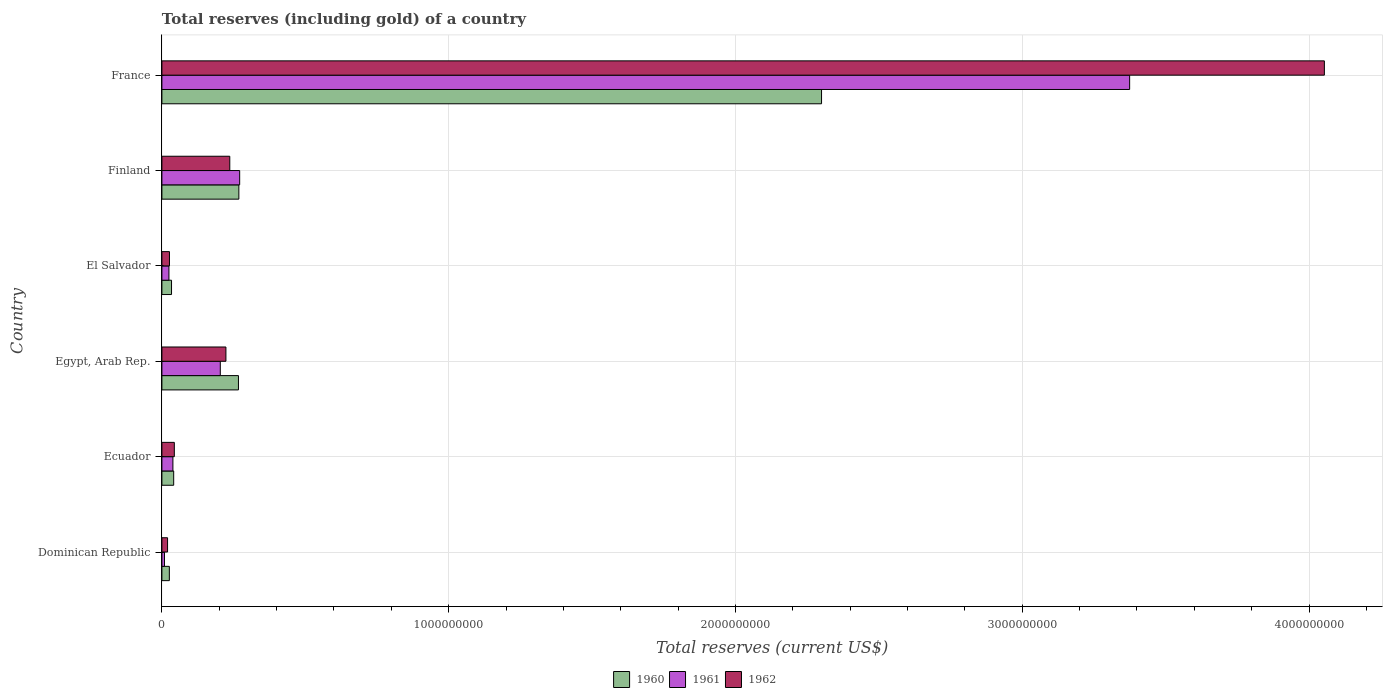How many different coloured bars are there?
Provide a short and direct response. 3. How many groups of bars are there?
Ensure brevity in your answer.  6. Are the number of bars on each tick of the Y-axis equal?
Make the answer very short. Yes. How many bars are there on the 1st tick from the bottom?
Keep it short and to the point. 3. What is the label of the 6th group of bars from the top?
Keep it short and to the point. Dominican Republic. What is the total reserves (including gold) in 1961 in Dominican Republic?
Provide a short and direct response. 9.02e+06. Across all countries, what is the maximum total reserves (including gold) in 1962?
Make the answer very short. 4.05e+09. Across all countries, what is the minimum total reserves (including gold) in 1961?
Ensure brevity in your answer.  9.02e+06. In which country was the total reserves (including gold) in 1961 minimum?
Keep it short and to the point. Dominican Republic. What is the total total reserves (including gold) in 1961 in the graph?
Give a very brief answer. 3.92e+09. What is the difference between the total reserves (including gold) in 1962 in Egypt, Arab Rep. and that in France?
Keep it short and to the point. -3.83e+09. What is the difference between the total reserves (including gold) in 1962 in El Salvador and the total reserves (including gold) in 1961 in Egypt, Arab Rep.?
Keep it short and to the point. -1.77e+08. What is the average total reserves (including gold) in 1962 per country?
Give a very brief answer. 7.67e+08. What is the difference between the total reserves (including gold) in 1962 and total reserves (including gold) in 1960 in Ecuador?
Ensure brevity in your answer.  2.27e+06. In how many countries, is the total reserves (including gold) in 1962 greater than 4000000000 US$?
Your answer should be compact. 1. What is the ratio of the total reserves (including gold) in 1961 in Ecuador to that in France?
Offer a terse response. 0.01. Is the difference between the total reserves (including gold) in 1962 in Dominican Republic and Ecuador greater than the difference between the total reserves (including gold) in 1960 in Dominican Republic and Ecuador?
Your answer should be compact. No. What is the difference between the highest and the second highest total reserves (including gold) in 1962?
Provide a succinct answer. 3.82e+09. What is the difference between the highest and the lowest total reserves (including gold) in 1961?
Keep it short and to the point. 3.37e+09. In how many countries, is the total reserves (including gold) in 1960 greater than the average total reserves (including gold) in 1960 taken over all countries?
Your answer should be very brief. 1. Is the sum of the total reserves (including gold) in 1962 in Egypt, Arab Rep. and France greater than the maximum total reserves (including gold) in 1961 across all countries?
Your answer should be compact. Yes. Is it the case that in every country, the sum of the total reserves (including gold) in 1961 and total reserves (including gold) in 1962 is greater than the total reserves (including gold) in 1960?
Give a very brief answer. Yes. Are all the bars in the graph horizontal?
Give a very brief answer. Yes. What is the difference between two consecutive major ticks on the X-axis?
Provide a short and direct response. 1.00e+09. Where does the legend appear in the graph?
Offer a terse response. Bottom center. How many legend labels are there?
Your answer should be very brief. 3. What is the title of the graph?
Offer a very short reply. Total reserves (including gold) of a country. Does "1977" appear as one of the legend labels in the graph?
Make the answer very short. No. What is the label or title of the X-axis?
Offer a very short reply. Total reserves (current US$). What is the label or title of the Y-axis?
Provide a succinct answer. Country. What is the Total reserves (current US$) of 1960 in Dominican Republic?
Your answer should be compact. 2.60e+07. What is the Total reserves (current US$) of 1961 in Dominican Republic?
Offer a very short reply. 9.02e+06. What is the Total reserves (current US$) in 1962 in Dominican Republic?
Keep it short and to the point. 1.97e+07. What is the Total reserves (current US$) in 1960 in Ecuador?
Give a very brief answer. 4.11e+07. What is the Total reserves (current US$) in 1961 in Ecuador?
Offer a very short reply. 3.84e+07. What is the Total reserves (current US$) of 1962 in Ecuador?
Give a very brief answer. 4.33e+07. What is the Total reserves (current US$) in 1960 in Egypt, Arab Rep.?
Give a very brief answer. 2.67e+08. What is the Total reserves (current US$) in 1961 in Egypt, Arab Rep.?
Your answer should be very brief. 2.04e+08. What is the Total reserves (current US$) of 1962 in Egypt, Arab Rep.?
Provide a short and direct response. 2.23e+08. What is the Total reserves (current US$) of 1960 in El Salvador?
Your response must be concise. 3.36e+07. What is the Total reserves (current US$) in 1961 in El Salvador?
Offer a very short reply. 2.46e+07. What is the Total reserves (current US$) in 1962 in El Salvador?
Your answer should be compact. 2.64e+07. What is the Total reserves (current US$) of 1960 in Finland?
Give a very brief answer. 2.68e+08. What is the Total reserves (current US$) of 1961 in Finland?
Provide a short and direct response. 2.71e+08. What is the Total reserves (current US$) in 1962 in Finland?
Provide a succinct answer. 2.37e+08. What is the Total reserves (current US$) in 1960 in France?
Give a very brief answer. 2.30e+09. What is the Total reserves (current US$) in 1961 in France?
Provide a succinct answer. 3.37e+09. What is the Total reserves (current US$) of 1962 in France?
Give a very brief answer. 4.05e+09. Across all countries, what is the maximum Total reserves (current US$) of 1960?
Give a very brief answer. 2.30e+09. Across all countries, what is the maximum Total reserves (current US$) in 1961?
Provide a succinct answer. 3.37e+09. Across all countries, what is the maximum Total reserves (current US$) of 1962?
Give a very brief answer. 4.05e+09. Across all countries, what is the minimum Total reserves (current US$) of 1960?
Offer a terse response. 2.60e+07. Across all countries, what is the minimum Total reserves (current US$) of 1961?
Give a very brief answer. 9.02e+06. Across all countries, what is the minimum Total reserves (current US$) in 1962?
Keep it short and to the point. 1.97e+07. What is the total Total reserves (current US$) in 1960 in the graph?
Your answer should be compact. 2.94e+09. What is the total Total reserves (current US$) of 1961 in the graph?
Keep it short and to the point. 3.92e+09. What is the total Total reserves (current US$) in 1962 in the graph?
Provide a succinct answer. 4.60e+09. What is the difference between the Total reserves (current US$) of 1960 in Dominican Republic and that in Ecuador?
Provide a short and direct response. -1.51e+07. What is the difference between the Total reserves (current US$) of 1961 in Dominican Republic and that in Ecuador?
Offer a very short reply. -2.94e+07. What is the difference between the Total reserves (current US$) in 1962 in Dominican Republic and that in Ecuador?
Provide a short and direct response. -2.36e+07. What is the difference between the Total reserves (current US$) of 1960 in Dominican Republic and that in Egypt, Arab Rep.?
Provide a succinct answer. -2.41e+08. What is the difference between the Total reserves (current US$) of 1961 in Dominican Republic and that in Egypt, Arab Rep.?
Provide a short and direct response. -1.95e+08. What is the difference between the Total reserves (current US$) in 1962 in Dominican Republic and that in Egypt, Arab Rep.?
Offer a very short reply. -2.04e+08. What is the difference between the Total reserves (current US$) in 1960 in Dominican Republic and that in El Salvador?
Give a very brief answer. -7.60e+06. What is the difference between the Total reserves (current US$) in 1961 in Dominican Republic and that in El Salvador?
Offer a terse response. -1.55e+07. What is the difference between the Total reserves (current US$) in 1962 in Dominican Republic and that in El Salvador?
Provide a short and direct response. -6.65e+06. What is the difference between the Total reserves (current US$) in 1960 in Dominican Republic and that in Finland?
Make the answer very short. -2.42e+08. What is the difference between the Total reserves (current US$) in 1961 in Dominican Republic and that in Finland?
Make the answer very short. -2.62e+08. What is the difference between the Total reserves (current US$) in 1962 in Dominican Republic and that in Finland?
Keep it short and to the point. -2.17e+08. What is the difference between the Total reserves (current US$) of 1960 in Dominican Republic and that in France?
Ensure brevity in your answer.  -2.27e+09. What is the difference between the Total reserves (current US$) of 1961 in Dominican Republic and that in France?
Give a very brief answer. -3.37e+09. What is the difference between the Total reserves (current US$) in 1962 in Dominican Republic and that in France?
Keep it short and to the point. -4.03e+09. What is the difference between the Total reserves (current US$) of 1960 in Ecuador and that in Egypt, Arab Rep.?
Offer a very short reply. -2.26e+08. What is the difference between the Total reserves (current US$) in 1961 in Ecuador and that in Egypt, Arab Rep.?
Offer a very short reply. -1.65e+08. What is the difference between the Total reserves (current US$) in 1962 in Ecuador and that in Egypt, Arab Rep.?
Provide a succinct answer. -1.80e+08. What is the difference between the Total reserves (current US$) of 1960 in Ecuador and that in El Salvador?
Your answer should be compact. 7.50e+06. What is the difference between the Total reserves (current US$) in 1961 in Ecuador and that in El Salvador?
Offer a terse response. 1.38e+07. What is the difference between the Total reserves (current US$) of 1962 in Ecuador and that in El Salvador?
Your answer should be very brief. 1.70e+07. What is the difference between the Total reserves (current US$) in 1960 in Ecuador and that in Finland?
Your response must be concise. -2.27e+08. What is the difference between the Total reserves (current US$) in 1961 in Ecuador and that in Finland?
Provide a short and direct response. -2.33e+08. What is the difference between the Total reserves (current US$) in 1962 in Ecuador and that in Finland?
Make the answer very short. -1.93e+08. What is the difference between the Total reserves (current US$) in 1960 in Ecuador and that in France?
Keep it short and to the point. -2.26e+09. What is the difference between the Total reserves (current US$) in 1961 in Ecuador and that in France?
Your response must be concise. -3.34e+09. What is the difference between the Total reserves (current US$) of 1962 in Ecuador and that in France?
Your response must be concise. -4.01e+09. What is the difference between the Total reserves (current US$) of 1960 in Egypt, Arab Rep. and that in El Salvador?
Offer a very short reply. 2.33e+08. What is the difference between the Total reserves (current US$) in 1961 in Egypt, Arab Rep. and that in El Salvador?
Provide a short and direct response. 1.79e+08. What is the difference between the Total reserves (current US$) of 1962 in Egypt, Arab Rep. and that in El Salvador?
Give a very brief answer. 1.97e+08. What is the difference between the Total reserves (current US$) in 1960 in Egypt, Arab Rep. and that in Finland?
Offer a very short reply. -1.40e+06. What is the difference between the Total reserves (current US$) of 1961 in Egypt, Arab Rep. and that in Finland?
Provide a succinct answer. -6.75e+07. What is the difference between the Total reserves (current US$) of 1962 in Egypt, Arab Rep. and that in Finland?
Offer a very short reply. -1.35e+07. What is the difference between the Total reserves (current US$) of 1960 in Egypt, Arab Rep. and that in France?
Ensure brevity in your answer.  -2.03e+09. What is the difference between the Total reserves (current US$) of 1961 in Egypt, Arab Rep. and that in France?
Offer a terse response. -3.17e+09. What is the difference between the Total reserves (current US$) in 1962 in Egypt, Arab Rep. and that in France?
Offer a very short reply. -3.83e+09. What is the difference between the Total reserves (current US$) of 1960 in El Salvador and that in Finland?
Provide a short and direct response. -2.35e+08. What is the difference between the Total reserves (current US$) in 1961 in El Salvador and that in Finland?
Ensure brevity in your answer.  -2.47e+08. What is the difference between the Total reserves (current US$) in 1962 in El Salvador and that in Finland?
Ensure brevity in your answer.  -2.10e+08. What is the difference between the Total reserves (current US$) in 1960 in El Salvador and that in France?
Make the answer very short. -2.27e+09. What is the difference between the Total reserves (current US$) in 1961 in El Salvador and that in France?
Make the answer very short. -3.35e+09. What is the difference between the Total reserves (current US$) in 1962 in El Salvador and that in France?
Your answer should be very brief. -4.03e+09. What is the difference between the Total reserves (current US$) of 1960 in Finland and that in France?
Your answer should be compact. -2.03e+09. What is the difference between the Total reserves (current US$) of 1961 in Finland and that in France?
Provide a short and direct response. -3.10e+09. What is the difference between the Total reserves (current US$) of 1962 in Finland and that in France?
Provide a short and direct response. -3.82e+09. What is the difference between the Total reserves (current US$) of 1960 in Dominican Republic and the Total reserves (current US$) of 1961 in Ecuador?
Keep it short and to the point. -1.24e+07. What is the difference between the Total reserves (current US$) in 1960 in Dominican Republic and the Total reserves (current US$) in 1962 in Ecuador?
Your response must be concise. -1.74e+07. What is the difference between the Total reserves (current US$) of 1961 in Dominican Republic and the Total reserves (current US$) of 1962 in Ecuador?
Your answer should be very brief. -3.43e+07. What is the difference between the Total reserves (current US$) in 1960 in Dominican Republic and the Total reserves (current US$) in 1961 in Egypt, Arab Rep.?
Provide a succinct answer. -1.78e+08. What is the difference between the Total reserves (current US$) of 1960 in Dominican Republic and the Total reserves (current US$) of 1962 in Egypt, Arab Rep.?
Provide a succinct answer. -1.97e+08. What is the difference between the Total reserves (current US$) in 1961 in Dominican Republic and the Total reserves (current US$) in 1962 in Egypt, Arab Rep.?
Give a very brief answer. -2.14e+08. What is the difference between the Total reserves (current US$) of 1960 in Dominican Republic and the Total reserves (current US$) of 1961 in El Salvador?
Provide a succinct answer. 1.42e+06. What is the difference between the Total reserves (current US$) in 1960 in Dominican Republic and the Total reserves (current US$) in 1962 in El Salvador?
Give a very brief answer. -3.91e+05. What is the difference between the Total reserves (current US$) in 1961 in Dominican Republic and the Total reserves (current US$) in 1962 in El Salvador?
Keep it short and to the point. -1.73e+07. What is the difference between the Total reserves (current US$) of 1960 in Dominican Republic and the Total reserves (current US$) of 1961 in Finland?
Your answer should be very brief. -2.45e+08. What is the difference between the Total reserves (current US$) of 1960 in Dominican Republic and the Total reserves (current US$) of 1962 in Finland?
Give a very brief answer. -2.11e+08. What is the difference between the Total reserves (current US$) of 1961 in Dominican Republic and the Total reserves (current US$) of 1962 in Finland?
Ensure brevity in your answer.  -2.28e+08. What is the difference between the Total reserves (current US$) in 1960 in Dominican Republic and the Total reserves (current US$) in 1961 in France?
Keep it short and to the point. -3.35e+09. What is the difference between the Total reserves (current US$) in 1960 in Dominican Republic and the Total reserves (current US$) in 1962 in France?
Your answer should be very brief. -4.03e+09. What is the difference between the Total reserves (current US$) of 1961 in Dominican Republic and the Total reserves (current US$) of 1962 in France?
Ensure brevity in your answer.  -4.04e+09. What is the difference between the Total reserves (current US$) of 1960 in Ecuador and the Total reserves (current US$) of 1961 in Egypt, Arab Rep.?
Ensure brevity in your answer.  -1.63e+08. What is the difference between the Total reserves (current US$) of 1960 in Ecuador and the Total reserves (current US$) of 1962 in Egypt, Arab Rep.?
Make the answer very short. -1.82e+08. What is the difference between the Total reserves (current US$) in 1961 in Ecuador and the Total reserves (current US$) in 1962 in Egypt, Arab Rep.?
Give a very brief answer. -1.85e+08. What is the difference between the Total reserves (current US$) of 1960 in Ecuador and the Total reserves (current US$) of 1961 in El Salvador?
Your response must be concise. 1.65e+07. What is the difference between the Total reserves (current US$) in 1960 in Ecuador and the Total reserves (current US$) in 1962 in El Salvador?
Provide a succinct answer. 1.47e+07. What is the difference between the Total reserves (current US$) of 1961 in Ecuador and the Total reserves (current US$) of 1962 in El Salvador?
Offer a very short reply. 1.20e+07. What is the difference between the Total reserves (current US$) in 1960 in Ecuador and the Total reserves (current US$) in 1961 in Finland?
Offer a terse response. -2.30e+08. What is the difference between the Total reserves (current US$) in 1960 in Ecuador and the Total reserves (current US$) in 1962 in Finland?
Your response must be concise. -1.96e+08. What is the difference between the Total reserves (current US$) in 1961 in Ecuador and the Total reserves (current US$) in 1962 in Finland?
Your answer should be compact. -1.98e+08. What is the difference between the Total reserves (current US$) of 1960 in Ecuador and the Total reserves (current US$) of 1961 in France?
Offer a very short reply. -3.33e+09. What is the difference between the Total reserves (current US$) of 1960 in Ecuador and the Total reserves (current US$) of 1962 in France?
Your answer should be very brief. -4.01e+09. What is the difference between the Total reserves (current US$) in 1961 in Ecuador and the Total reserves (current US$) in 1962 in France?
Your answer should be very brief. -4.02e+09. What is the difference between the Total reserves (current US$) in 1960 in Egypt, Arab Rep. and the Total reserves (current US$) in 1961 in El Salvador?
Offer a very short reply. 2.42e+08. What is the difference between the Total reserves (current US$) in 1960 in Egypt, Arab Rep. and the Total reserves (current US$) in 1962 in El Salvador?
Offer a very short reply. 2.41e+08. What is the difference between the Total reserves (current US$) of 1961 in Egypt, Arab Rep. and the Total reserves (current US$) of 1962 in El Salvador?
Ensure brevity in your answer.  1.77e+08. What is the difference between the Total reserves (current US$) in 1960 in Egypt, Arab Rep. and the Total reserves (current US$) in 1961 in Finland?
Make the answer very short. -4.20e+06. What is the difference between the Total reserves (current US$) in 1960 in Egypt, Arab Rep. and the Total reserves (current US$) in 1962 in Finland?
Your response must be concise. 3.03e+07. What is the difference between the Total reserves (current US$) of 1961 in Egypt, Arab Rep. and the Total reserves (current US$) of 1962 in Finland?
Give a very brief answer. -3.31e+07. What is the difference between the Total reserves (current US$) of 1960 in Egypt, Arab Rep. and the Total reserves (current US$) of 1961 in France?
Your response must be concise. -3.11e+09. What is the difference between the Total reserves (current US$) of 1960 in Egypt, Arab Rep. and the Total reserves (current US$) of 1962 in France?
Give a very brief answer. -3.79e+09. What is the difference between the Total reserves (current US$) in 1961 in Egypt, Arab Rep. and the Total reserves (current US$) in 1962 in France?
Offer a terse response. -3.85e+09. What is the difference between the Total reserves (current US$) in 1960 in El Salvador and the Total reserves (current US$) in 1961 in Finland?
Your answer should be compact. -2.38e+08. What is the difference between the Total reserves (current US$) of 1960 in El Salvador and the Total reserves (current US$) of 1962 in Finland?
Provide a succinct answer. -2.03e+08. What is the difference between the Total reserves (current US$) in 1961 in El Salvador and the Total reserves (current US$) in 1962 in Finland?
Your answer should be very brief. -2.12e+08. What is the difference between the Total reserves (current US$) of 1960 in El Salvador and the Total reserves (current US$) of 1961 in France?
Offer a very short reply. -3.34e+09. What is the difference between the Total reserves (current US$) of 1960 in El Salvador and the Total reserves (current US$) of 1962 in France?
Keep it short and to the point. -4.02e+09. What is the difference between the Total reserves (current US$) in 1961 in El Salvador and the Total reserves (current US$) in 1962 in France?
Your answer should be compact. -4.03e+09. What is the difference between the Total reserves (current US$) of 1960 in Finland and the Total reserves (current US$) of 1961 in France?
Keep it short and to the point. -3.11e+09. What is the difference between the Total reserves (current US$) of 1960 in Finland and the Total reserves (current US$) of 1962 in France?
Make the answer very short. -3.79e+09. What is the difference between the Total reserves (current US$) of 1961 in Finland and the Total reserves (current US$) of 1962 in France?
Ensure brevity in your answer.  -3.78e+09. What is the average Total reserves (current US$) in 1960 per country?
Ensure brevity in your answer.  4.89e+08. What is the average Total reserves (current US$) of 1961 per country?
Provide a short and direct response. 6.54e+08. What is the average Total reserves (current US$) in 1962 per country?
Provide a succinct answer. 7.67e+08. What is the difference between the Total reserves (current US$) of 1960 and Total reserves (current US$) of 1961 in Dominican Republic?
Provide a succinct answer. 1.70e+07. What is the difference between the Total reserves (current US$) of 1960 and Total reserves (current US$) of 1962 in Dominican Republic?
Keep it short and to the point. 6.26e+06. What is the difference between the Total reserves (current US$) of 1961 and Total reserves (current US$) of 1962 in Dominican Republic?
Offer a terse response. -1.07e+07. What is the difference between the Total reserves (current US$) in 1960 and Total reserves (current US$) in 1961 in Ecuador?
Your answer should be compact. 2.68e+06. What is the difference between the Total reserves (current US$) of 1960 and Total reserves (current US$) of 1962 in Ecuador?
Keep it short and to the point. -2.27e+06. What is the difference between the Total reserves (current US$) in 1961 and Total reserves (current US$) in 1962 in Ecuador?
Keep it short and to the point. -4.95e+06. What is the difference between the Total reserves (current US$) in 1960 and Total reserves (current US$) in 1961 in Egypt, Arab Rep.?
Your answer should be compact. 6.33e+07. What is the difference between the Total reserves (current US$) of 1960 and Total reserves (current US$) of 1962 in Egypt, Arab Rep.?
Keep it short and to the point. 4.37e+07. What is the difference between the Total reserves (current US$) of 1961 and Total reserves (current US$) of 1962 in Egypt, Arab Rep.?
Provide a succinct answer. -1.96e+07. What is the difference between the Total reserves (current US$) of 1960 and Total reserves (current US$) of 1961 in El Salvador?
Your answer should be compact. 9.02e+06. What is the difference between the Total reserves (current US$) of 1960 and Total reserves (current US$) of 1962 in El Salvador?
Offer a very short reply. 7.21e+06. What is the difference between the Total reserves (current US$) of 1961 and Total reserves (current US$) of 1962 in El Salvador?
Ensure brevity in your answer.  -1.81e+06. What is the difference between the Total reserves (current US$) of 1960 and Total reserves (current US$) of 1961 in Finland?
Make the answer very short. -2.81e+06. What is the difference between the Total reserves (current US$) in 1960 and Total reserves (current US$) in 1962 in Finland?
Provide a succinct answer. 3.17e+07. What is the difference between the Total reserves (current US$) in 1961 and Total reserves (current US$) in 1962 in Finland?
Your response must be concise. 3.45e+07. What is the difference between the Total reserves (current US$) in 1960 and Total reserves (current US$) in 1961 in France?
Keep it short and to the point. -1.07e+09. What is the difference between the Total reserves (current US$) in 1960 and Total reserves (current US$) in 1962 in France?
Your answer should be compact. -1.75e+09. What is the difference between the Total reserves (current US$) in 1961 and Total reserves (current US$) in 1962 in France?
Ensure brevity in your answer.  -6.79e+08. What is the ratio of the Total reserves (current US$) in 1960 in Dominican Republic to that in Ecuador?
Your answer should be compact. 0.63. What is the ratio of the Total reserves (current US$) of 1961 in Dominican Republic to that in Ecuador?
Provide a succinct answer. 0.23. What is the ratio of the Total reserves (current US$) of 1962 in Dominican Republic to that in Ecuador?
Your response must be concise. 0.45. What is the ratio of the Total reserves (current US$) in 1960 in Dominican Republic to that in Egypt, Arab Rep.?
Your answer should be very brief. 0.1. What is the ratio of the Total reserves (current US$) of 1961 in Dominican Republic to that in Egypt, Arab Rep.?
Give a very brief answer. 0.04. What is the ratio of the Total reserves (current US$) of 1962 in Dominican Republic to that in Egypt, Arab Rep.?
Your response must be concise. 0.09. What is the ratio of the Total reserves (current US$) of 1960 in Dominican Republic to that in El Salvador?
Offer a very short reply. 0.77. What is the ratio of the Total reserves (current US$) of 1961 in Dominican Republic to that in El Salvador?
Ensure brevity in your answer.  0.37. What is the ratio of the Total reserves (current US$) in 1962 in Dominican Republic to that in El Salvador?
Your response must be concise. 0.75. What is the ratio of the Total reserves (current US$) of 1960 in Dominican Republic to that in Finland?
Your answer should be compact. 0.1. What is the ratio of the Total reserves (current US$) in 1961 in Dominican Republic to that in Finland?
Make the answer very short. 0.03. What is the ratio of the Total reserves (current US$) of 1962 in Dominican Republic to that in Finland?
Offer a very short reply. 0.08. What is the ratio of the Total reserves (current US$) in 1960 in Dominican Republic to that in France?
Your response must be concise. 0.01. What is the ratio of the Total reserves (current US$) in 1961 in Dominican Republic to that in France?
Give a very brief answer. 0. What is the ratio of the Total reserves (current US$) of 1962 in Dominican Republic to that in France?
Make the answer very short. 0. What is the ratio of the Total reserves (current US$) of 1960 in Ecuador to that in Egypt, Arab Rep.?
Your answer should be compact. 0.15. What is the ratio of the Total reserves (current US$) in 1961 in Ecuador to that in Egypt, Arab Rep.?
Provide a short and direct response. 0.19. What is the ratio of the Total reserves (current US$) of 1962 in Ecuador to that in Egypt, Arab Rep.?
Offer a very short reply. 0.19. What is the ratio of the Total reserves (current US$) in 1960 in Ecuador to that in El Salvador?
Make the answer very short. 1.22. What is the ratio of the Total reserves (current US$) in 1961 in Ecuador to that in El Salvador?
Your answer should be compact. 1.56. What is the ratio of the Total reserves (current US$) in 1962 in Ecuador to that in El Salvador?
Ensure brevity in your answer.  1.64. What is the ratio of the Total reserves (current US$) of 1960 in Ecuador to that in Finland?
Your answer should be compact. 0.15. What is the ratio of the Total reserves (current US$) of 1961 in Ecuador to that in Finland?
Provide a succinct answer. 0.14. What is the ratio of the Total reserves (current US$) in 1962 in Ecuador to that in Finland?
Give a very brief answer. 0.18. What is the ratio of the Total reserves (current US$) in 1960 in Ecuador to that in France?
Offer a very short reply. 0.02. What is the ratio of the Total reserves (current US$) in 1961 in Ecuador to that in France?
Keep it short and to the point. 0.01. What is the ratio of the Total reserves (current US$) of 1962 in Ecuador to that in France?
Your answer should be very brief. 0.01. What is the ratio of the Total reserves (current US$) in 1960 in Egypt, Arab Rep. to that in El Salvador?
Offer a terse response. 7.95. What is the ratio of the Total reserves (current US$) of 1961 in Egypt, Arab Rep. to that in El Salvador?
Keep it short and to the point. 8.29. What is the ratio of the Total reserves (current US$) in 1962 in Egypt, Arab Rep. to that in El Salvador?
Ensure brevity in your answer.  8.47. What is the ratio of the Total reserves (current US$) of 1961 in Egypt, Arab Rep. to that in Finland?
Give a very brief answer. 0.75. What is the ratio of the Total reserves (current US$) of 1962 in Egypt, Arab Rep. to that in Finland?
Keep it short and to the point. 0.94. What is the ratio of the Total reserves (current US$) of 1960 in Egypt, Arab Rep. to that in France?
Ensure brevity in your answer.  0.12. What is the ratio of the Total reserves (current US$) in 1961 in Egypt, Arab Rep. to that in France?
Give a very brief answer. 0.06. What is the ratio of the Total reserves (current US$) in 1962 in Egypt, Arab Rep. to that in France?
Provide a succinct answer. 0.06. What is the ratio of the Total reserves (current US$) in 1960 in El Salvador to that in Finland?
Provide a succinct answer. 0.13. What is the ratio of the Total reserves (current US$) in 1961 in El Salvador to that in Finland?
Keep it short and to the point. 0.09. What is the ratio of the Total reserves (current US$) in 1962 in El Salvador to that in Finland?
Offer a terse response. 0.11. What is the ratio of the Total reserves (current US$) of 1960 in El Salvador to that in France?
Your answer should be compact. 0.01. What is the ratio of the Total reserves (current US$) of 1961 in El Salvador to that in France?
Provide a short and direct response. 0.01. What is the ratio of the Total reserves (current US$) of 1962 in El Salvador to that in France?
Make the answer very short. 0.01. What is the ratio of the Total reserves (current US$) of 1960 in Finland to that in France?
Your response must be concise. 0.12. What is the ratio of the Total reserves (current US$) in 1961 in Finland to that in France?
Your answer should be compact. 0.08. What is the ratio of the Total reserves (current US$) of 1962 in Finland to that in France?
Your answer should be very brief. 0.06. What is the difference between the highest and the second highest Total reserves (current US$) of 1960?
Provide a succinct answer. 2.03e+09. What is the difference between the highest and the second highest Total reserves (current US$) of 1961?
Give a very brief answer. 3.10e+09. What is the difference between the highest and the second highest Total reserves (current US$) in 1962?
Offer a terse response. 3.82e+09. What is the difference between the highest and the lowest Total reserves (current US$) of 1960?
Your answer should be very brief. 2.27e+09. What is the difference between the highest and the lowest Total reserves (current US$) in 1961?
Ensure brevity in your answer.  3.37e+09. What is the difference between the highest and the lowest Total reserves (current US$) of 1962?
Provide a short and direct response. 4.03e+09. 